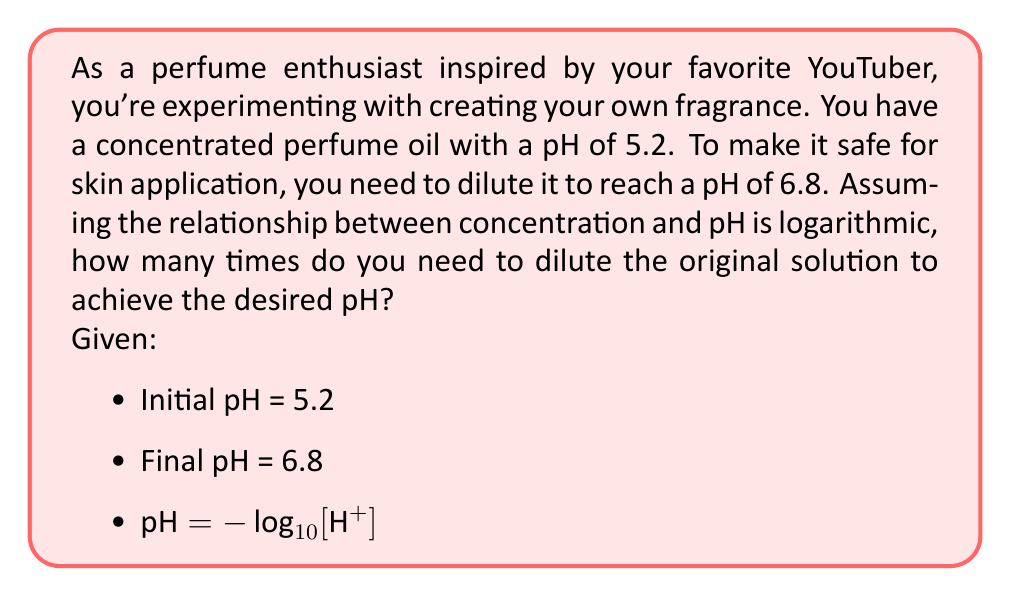Help me with this question. Let's approach this step-by-step:

1) First, recall that pH is defined as the negative logarithm (base 10) of the hydrogen ion concentration:

   $\text{pH} = -\log_{10}[\text{H}^+]$

2) We can rearrange this to find the hydrogen ion concentration:

   $[\text{H}^+] = 10^{-\text{pH}}$

3) Let's calculate the initial and final hydrogen ion concentrations:

   Initial: $[\text{H}^+]_i = 10^{-5.2}$
   Final: $[\text{H}^+]_f = 10^{-6.8}$

4) The dilution factor is the ratio of the initial to final concentrations:

   $\text{Dilution factor} = \frac{[\text{H}^+]_i}{[\text{H}^+]_f} = \frac{10^{-5.2}}{10^{-6.8}}$

5) We can simplify this:

   $\text{Dilution factor} = 10^{-5.2 + 6.8} = 10^{1.6}$

6) Now, let's calculate this value:

   $\text{Dilution factor} = 10^{1.6} \approx 39.81$
Answer: You need to dilute the original perfume solution approximately 39.81 times to achieve the desired pH of 6.8. 